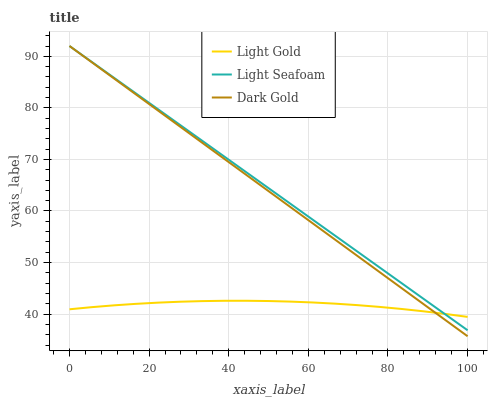Does Dark Gold have the minimum area under the curve?
Answer yes or no. No. Does Dark Gold have the maximum area under the curve?
Answer yes or no. No. Is Dark Gold the smoothest?
Answer yes or no. No. Is Dark Gold the roughest?
Answer yes or no. No. Does Light Gold have the lowest value?
Answer yes or no. No. Does Light Gold have the highest value?
Answer yes or no. No. 